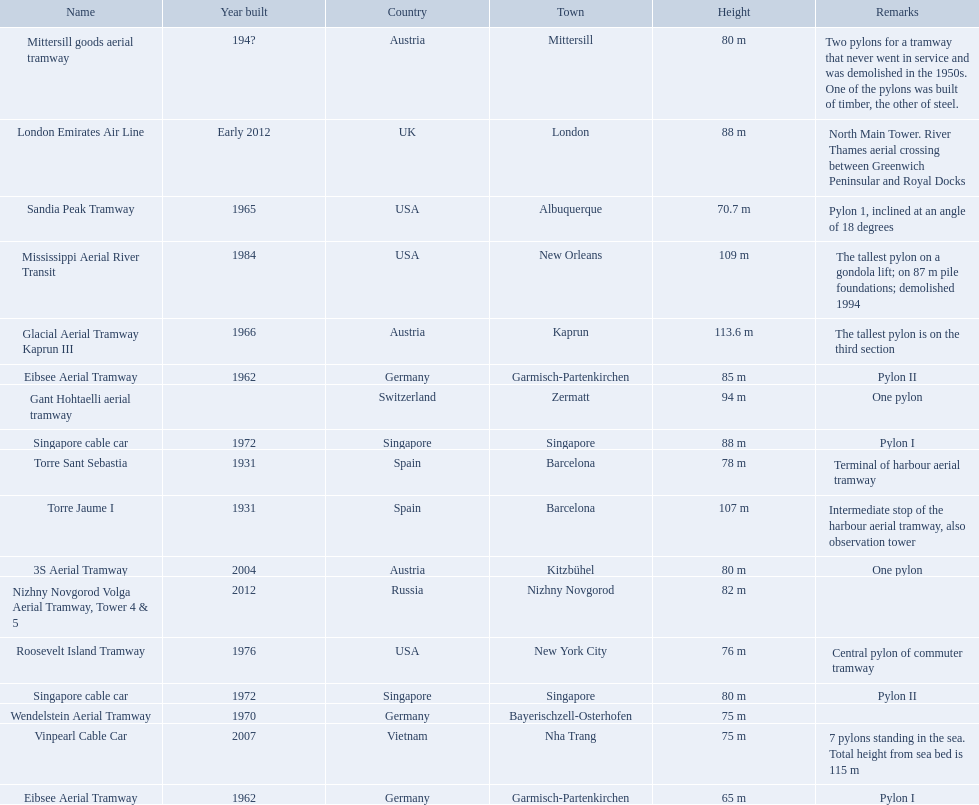How many aerial lift pylon's on the list are located in the usa? Mississippi Aerial River Transit, Roosevelt Island Tramway, Sandia Peak Tramway. Of the pylon's located in the usa how many were built after 1970? Mississippi Aerial River Transit, Roosevelt Island Tramway. Of the pylon's built after 1970 which is the tallest pylon on a gondola lift? Mississippi Aerial River Transit. How many meters is the tallest pylon on a gondola lift? 109 m. 